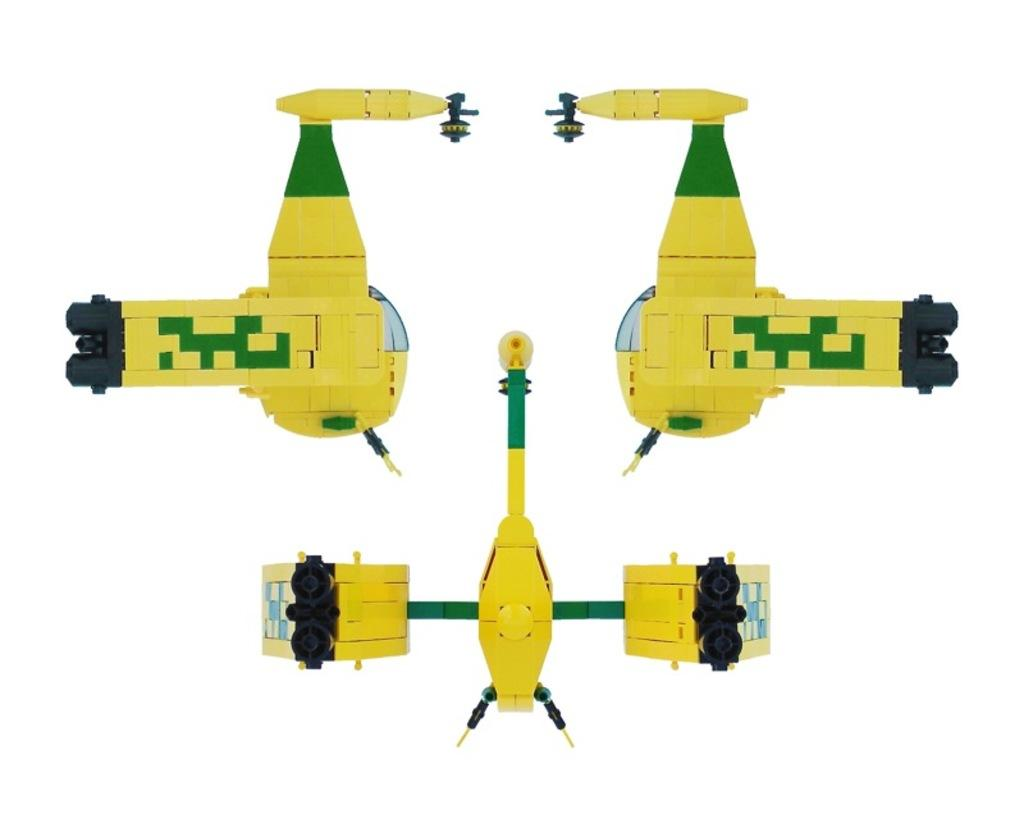What type of toys are present in the image? There are toys made up of building blocks in the image. What color is the background of the image? The background of the image is white in color. How does the ink on the toys change color when exposed to the wind in the image? There is no ink on the toys, and there is no wind present in the image. 